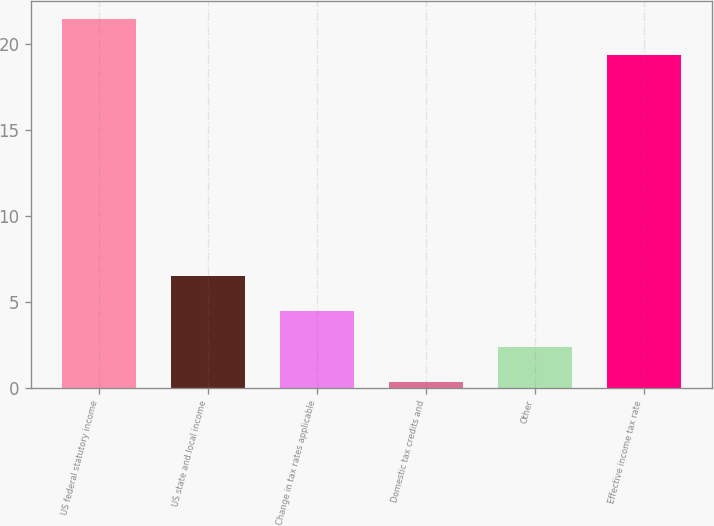Convert chart. <chart><loc_0><loc_0><loc_500><loc_500><bar_chart><fcel>US federal statutory income<fcel>US state and local income<fcel>Change in tax rates applicable<fcel>Domestic tax credits and<fcel>Other<fcel>Effective income tax rate<nl><fcel>21.44<fcel>6.51<fcel>4.44<fcel>0.3<fcel>2.37<fcel>19.37<nl></chart> 